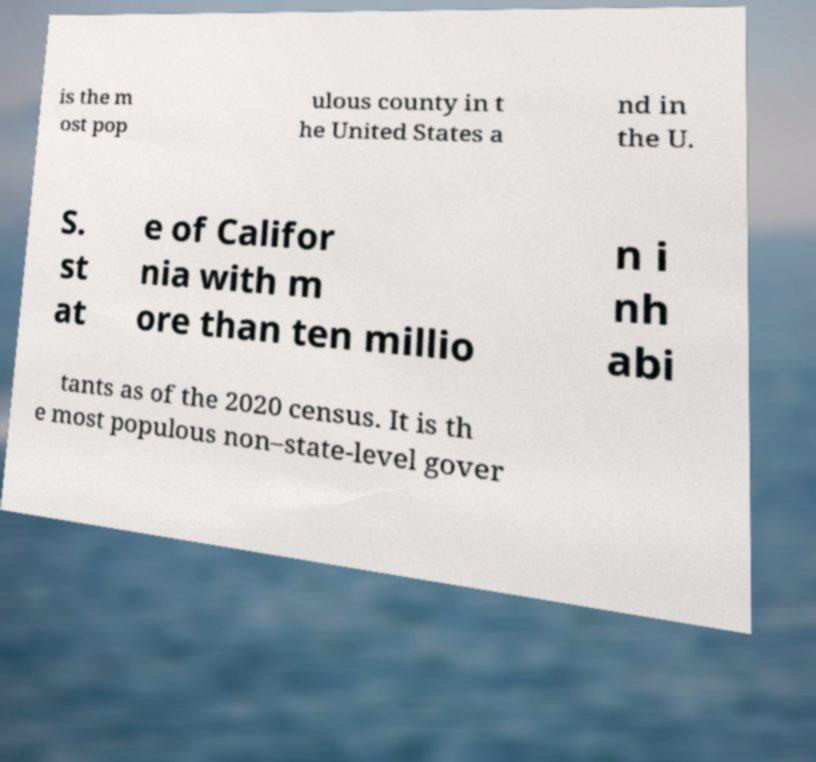Please read and relay the text visible in this image. What does it say? is the m ost pop ulous county in t he United States a nd in the U. S. st at e of Califor nia with m ore than ten millio n i nh abi tants as of the 2020 census. It is th e most populous non–state-level gover 